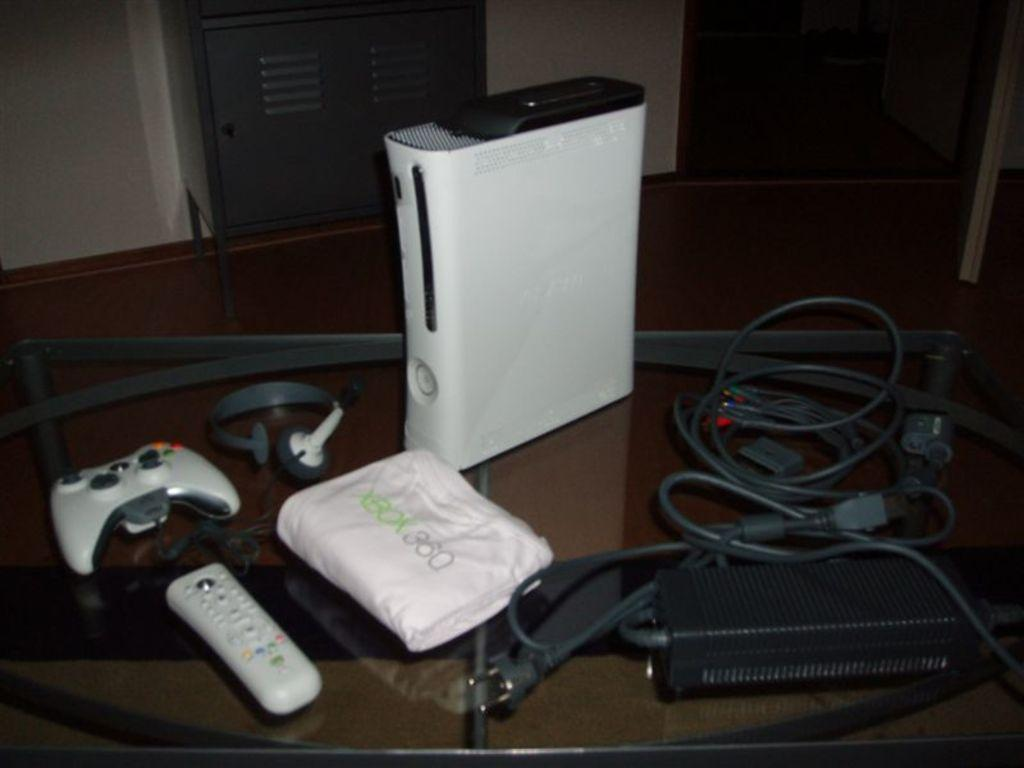<image>
Render a clear and concise summary of the photo. An Xbox 360, a controller, some peripherals and a headset 